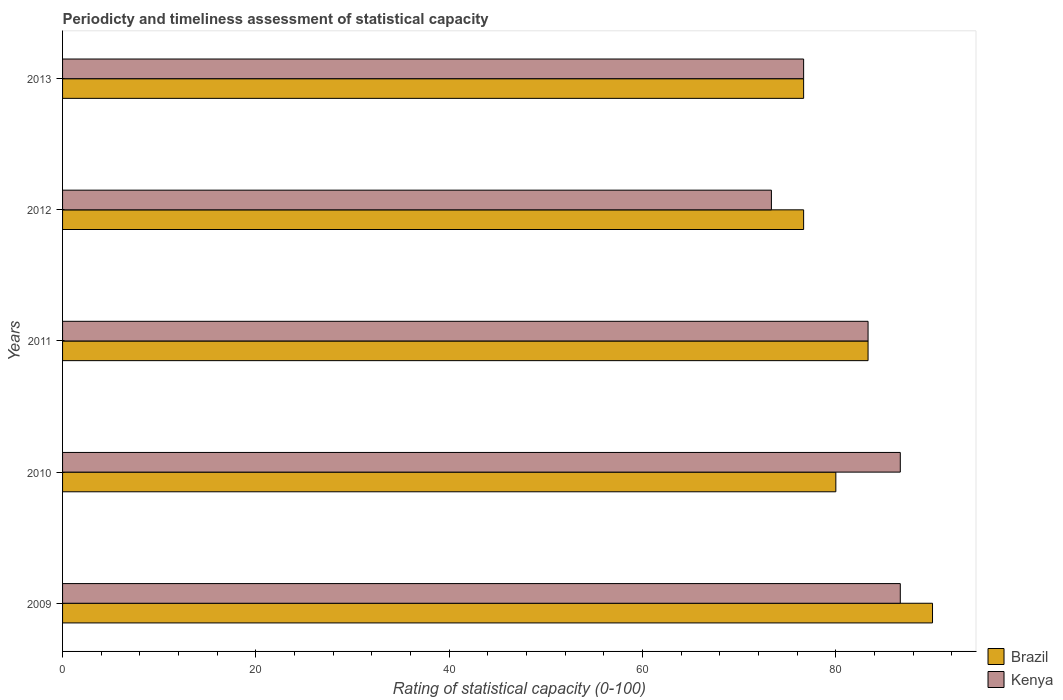Are the number of bars per tick equal to the number of legend labels?
Keep it short and to the point. Yes. How many bars are there on the 5th tick from the top?
Offer a very short reply. 2. How many bars are there on the 5th tick from the bottom?
Make the answer very short. 2. What is the rating of statistical capacity in Brazil in 2013?
Give a very brief answer. 76.67. Across all years, what is the maximum rating of statistical capacity in Kenya?
Provide a succinct answer. 86.67. Across all years, what is the minimum rating of statistical capacity in Kenya?
Your response must be concise. 73.33. In which year was the rating of statistical capacity in Kenya maximum?
Ensure brevity in your answer.  2009. What is the total rating of statistical capacity in Brazil in the graph?
Provide a succinct answer. 406.67. What is the difference between the rating of statistical capacity in Brazil in 2009 and that in 2013?
Offer a terse response. 13.33. What is the difference between the rating of statistical capacity in Kenya in 2011 and the rating of statistical capacity in Brazil in 2013?
Offer a terse response. 6.67. What is the average rating of statistical capacity in Kenya per year?
Give a very brief answer. 81.33. In the year 2010, what is the difference between the rating of statistical capacity in Kenya and rating of statistical capacity in Brazil?
Your response must be concise. 6.67. What is the ratio of the rating of statistical capacity in Kenya in 2009 to that in 2013?
Keep it short and to the point. 1.13. Is the rating of statistical capacity in Brazil in 2010 less than that in 2012?
Give a very brief answer. No. What is the difference between the highest and the second highest rating of statistical capacity in Brazil?
Your response must be concise. 6.67. What is the difference between the highest and the lowest rating of statistical capacity in Brazil?
Provide a succinct answer. 13.33. Is the sum of the rating of statistical capacity in Brazil in 2010 and 2012 greater than the maximum rating of statistical capacity in Kenya across all years?
Offer a very short reply. Yes. How many years are there in the graph?
Provide a short and direct response. 5. What is the difference between two consecutive major ticks on the X-axis?
Keep it short and to the point. 20. Are the values on the major ticks of X-axis written in scientific E-notation?
Offer a terse response. No. Where does the legend appear in the graph?
Offer a terse response. Bottom right. How are the legend labels stacked?
Give a very brief answer. Vertical. What is the title of the graph?
Offer a terse response. Periodicty and timeliness assessment of statistical capacity. Does "Colombia" appear as one of the legend labels in the graph?
Your answer should be very brief. No. What is the label or title of the X-axis?
Keep it short and to the point. Rating of statistical capacity (0-100). What is the Rating of statistical capacity (0-100) of Kenya in 2009?
Keep it short and to the point. 86.67. What is the Rating of statistical capacity (0-100) in Kenya in 2010?
Provide a short and direct response. 86.67. What is the Rating of statistical capacity (0-100) in Brazil in 2011?
Offer a very short reply. 83.33. What is the Rating of statistical capacity (0-100) of Kenya in 2011?
Provide a succinct answer. 83.33. What is the Rating of statistical capacity (0-100) in Brazil in 2012?
Your answer should be compact. 76.67. What is the Rating of statistical capacity (0-100) of Kenya in 2012?
Offer a very short reply. 73.33. What is the Rating of statistical capacity (0-100) of Brazil in 2013?
Offer a terse response. 76.67. What is the Rating of statistical capacity (0-100) in Kenya in 2013?
Your answer should be compact. 76.67. Across all years, what is the maximum Rating of statistical capacity (0-100) of Kenya?
Keep it short and to the point. 86.67. Across all years, what is the minimum Rating of statistical capacity (0-100) in Brazil?
Provide a short and direct response. 76.67. Across all years, what is the minimum Rating of statistical capacity (0-100) of Kenya?
Offer a terse response. 73.33. What is the total Rating of statistical capacity (0-100) in Brazil in the graph?
Offer a very short reply. 406.67. What is the total Rating of statistical capacity (0-100) of Kenya in the graph?
Ensure brevity in your answer.  406.67. What is the difference between the Rating of statistical capacity (0-100) in Brazil in 2009 and that in 2010?
Keep it short and to the point. 10. What is the difference between the Rating of statistical capacity (0-100) of Kenya in 2009 and that in 2010?
Offer a very short reply. 0. What is the difference between the Rating of statistical capacity (0-100) in Brazil in 2009 and that in 2011?
Your answer should be compact. 6.67. What is the difference between the Rating of statistical capacity (0-100) in Brazil in 2009 and that in 2012?
Your answer should be very brief. 13.33. What is the difference between the Rating of statistical capacity (0-100) of Kenya in 2009 and that in 2012?
Keep it short and to the point. 13.33. What is the difference between the Rating of statistical capacity (0-100) in Brazil in 2009 and that in 2013?
Keep it short and to the point. 13.33. What is the difference between the Rating of statistical capacity (0-100) of Kenya in 2009 and that in 2013?
Make the answer very short. 10. What is the difference between the Rating of statistical capacity (0-100) of Brazil in 2010 and that in 2011?
Offer a terse response. -3.33. What is the difference between the Rating of statistical capacity (0-100) in Brazil in 2010 and that in 2012?
Ensure brevity in your answer.  3.33. What is the difference between the Rating of statistical capacity (0-100) of Kenya in 2010 and that in 2012?
Provide a succinct answer. 13.33. What is the difference between the Rating of statistical capacity (0-100) in Kenya in 2010 and that in 2013?
Offer a terse response. 10. What is the difference between the Rating of statistical capacity (0-100) in Kenya in 2011 and that in 2012?
Your response must be concise. 10. What is the difference between the Rating of statistical capacity (0-100) of Kenya in 2011 and that in 2013?
Offer a very short reply. 6.67. What is the difference between the Rating of statistical capacity (0-100) of Brazil in 2012 and that in 2013?
Give a very brief answer. 0. What is the difference between the Rating of statistical capacity (0-100) of Kenya in 2012 and that in 2013?
Ensure brevity in your answer.  -3.33. What is the difference between the Rating of statistical capacity (0-100) of Brazil in 2009 and the Rating of statistical capacity (0-100) of Kenya in 2012?
Make the answer very short. 16.67. What is the difference between the Rating of statistical capacity (0-100) of Brazil in 2009 and the Rating of statistical capacity (0-100) of Kenya in 2013?
Offer a terse response. 13.33. What is the difference between the Rating of statistical capacity (0-100) in Brazil in 2010 and the Rating of statistical capacity (0-100) in Kenya in 2011?
Your response must be concise. -3.33. What is the difference between the Rating of statistical capacity (0-100) of Brazil in 2011 and the Rating of statistical capacity (0-100) of Kenya in 2012?
Your answer should be compact. 10. What is the average Rating of statistical capacity (0-100) of Brazil per year?
Give a very brief answer. 81.33. What is the average Rating of statistical capacity (0-100) in Kenya per year?
Provide a short and direct response. 81.33. In the year 2010, what is the difference between the Rating of statistical capacity (0-100) of Brazil and Rating of statistical capacity (0-100) of Kenya?
Ensure brevity in your answer.  -6.67. What is the ratio of the Rating of statistical capacity (0-100) of Brazil in 2009 to that in 2011?
Make the answer very short. 1.08. What is the ratio of the Rating of statistical capacity (0-100) of Kenya in 2009 to that in 2011?
Provide a succinct answer. 1.04. What is the ratio of the Rating of statistical capacity (0-100) of Brazil in 2009 to that in 2012?
Give a very brief answer. 1.17. What is the ratio of the Rating of statistical capacity (0-100) of Kenya in 2009 to that in 2012?
Provide a succinct answer. 1.18. What is the ratio of the Rating of statistical capacity (0-100) of Brazil in 2009 to that in 2013?
Provide a succinct answer. 1.17. What is the ratio of the Rating of statistical capacity (0-100) of Kenya in 2009 to that in 2013?
Ensure brevity in your answer.  1.13. What is the ratio of the Rating of statistical capacity (0-100) of Brazil in 2010 to that in 2011?
Your answer should be compact. 0.96. What is the ratio of the Rating of statistical capacity (0-100) of Kenya in 2010 to that in 2011?
Your response must be concise. 1.04. What is the ratio of the Rating of statistical capacity (0-100) of Brazil in 2010 to that in 2012?
Provide a short and direct response. 1.04. What is the ratio of the Rating of statistical capacity (0-100) of Kenya in 2010 to that in 2012?
Give a very brief answer. 1.18. What is the ratio of the Rating of statistical capacity (0-100) in Brazil in 2010 to that in 2013?
Keep it short and to the point. 1.04. What is the ratio of the Rating of statistical capacity (0-100) in Kenya in 2010 to that in 2013?
Make the answer very short. 1.13. What is the ratio of the Rating of statistical capacity (0-100) in Brazil in 2011 to that in 2012?
Your response must be concise. 1.09. What is the ratio of the Rating of statistical capacity (0-100) in Kenya in 2011 to that in 2012?
Ensure brevity in your answer.  1.14. What is the ratio of the Rating of statistical capacity (0-100) in Brazil in 2011 to that in 2013?
Offer a terse response. 1.09. What is the ratio of the Rating of statistical capacity (0-100) of Kenya in 2011 to that in 2013?
Provide a succinct answer. 1.09. What is the ratio of the Rating of statistical capacity (0-100) of Kenya in 2012 to that in 2013?
Provide a succinct answer. 0.96. What is the difference between the highest and the lowest Rating of statistical capacity (0-100) of Brazil?
Offer a very short reply. 13.33. What is the difference between the highest and the lowest Rating of statistical capacity (0-100) of Kenya?
Make the answer very short. 13.33. 